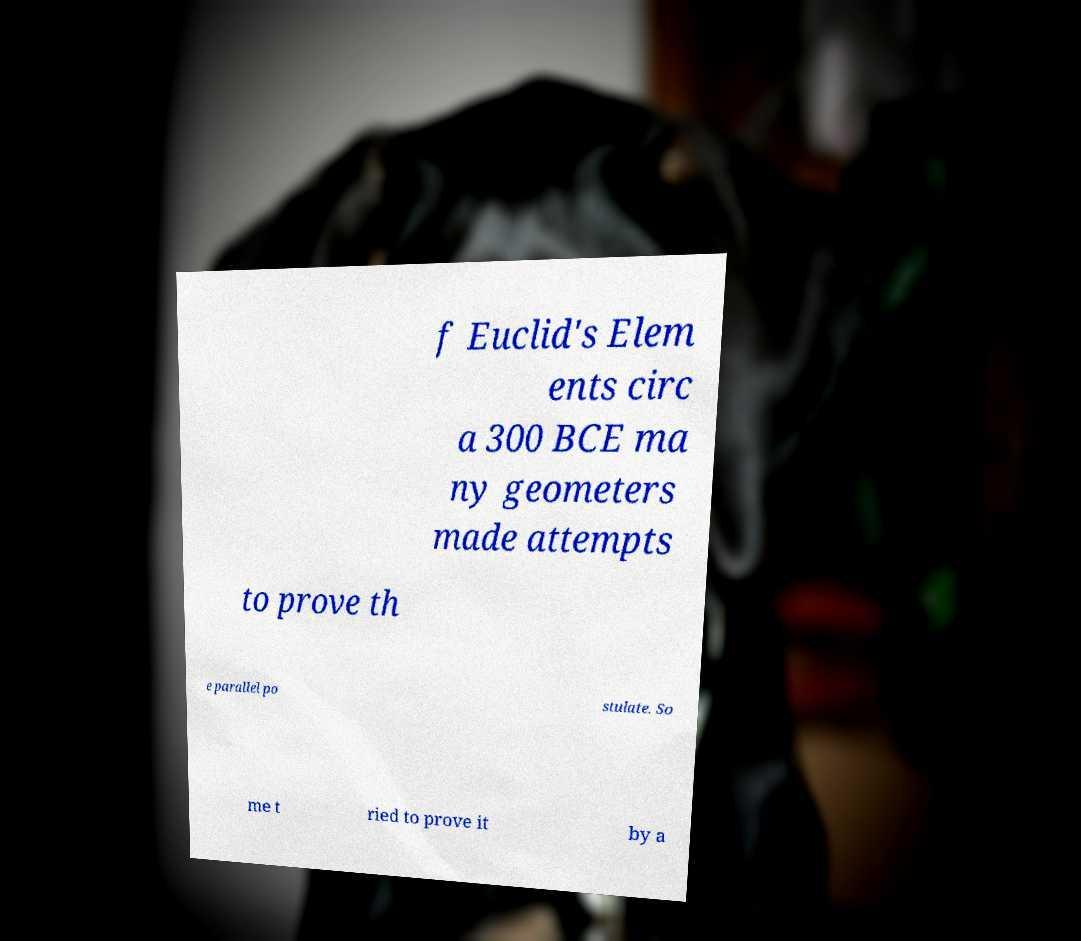For documentation purposes, I need the text within this image transcribed. Could you provide that? f Euclid's Elem ents circ a 300 BCE ma ny geometers made attempts to prove th e parallel po stulate. So me t ried to prove it by a 